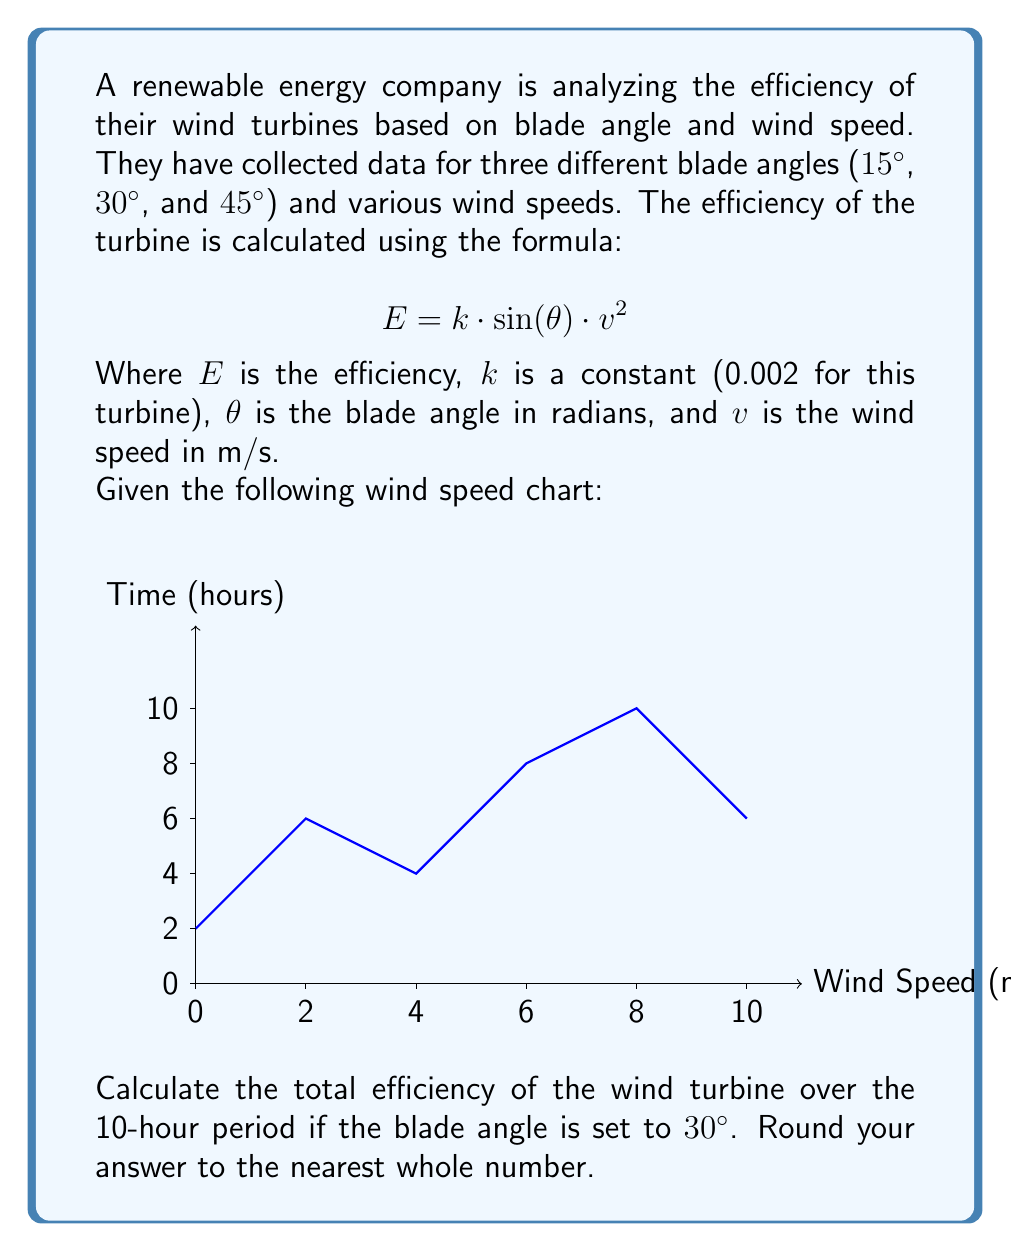Could you help me with this problem? Let's approach this step-by-step:

1) First, we need to convert the blade angle from degrees to radians:
   $30° = 30 \cdot \frac{\pi}{180} = \frac{\pi}{6}$ radians

2) Now, we can simplify our efficiency formula:
   $$E = 0.002 \cdot \sin(\frac{\pi}{6}) \cdot v^2 = 0.001 \cdot v^2$$

3) Looking at the wind speed chart, we can approximate the wind speed for each 2-hour interval:
   0-2 hours: 2 m/s
   2-4 hours: 2.5 m/s
   4-6 hours: 3 m/s
   6-8 hours: 4.5 m/s
   8-10 hours: 4 m/s

4) Now, let's calculate the efficiency for each interval:
   0-2 hours: $E = 0.001 \cdot 2^2 = 0.004$
   2-4 hours: $E = 0.001 \cdot 2.5^2 = 0.00625$
   4-6 hours: $E = 0.001 \cdot 3^2 = 0.009$
   6-8 hours: $E = 0.001 \cdot 4.5^2 = 0.02025$
   8-10 hours: $E = 0.001 \cdot 4^2 = 0.016$

5) To get the total efficiency, we sum these values:
   $E_{total} = 0.004 + 0.00625 + 0.009 + 0.02025 + 0.016 = 0.05550$

6) Rounding to the nearest whole number:
   $0.05550 \approx 0.06 \approx 6\%$
Answer: 6% 